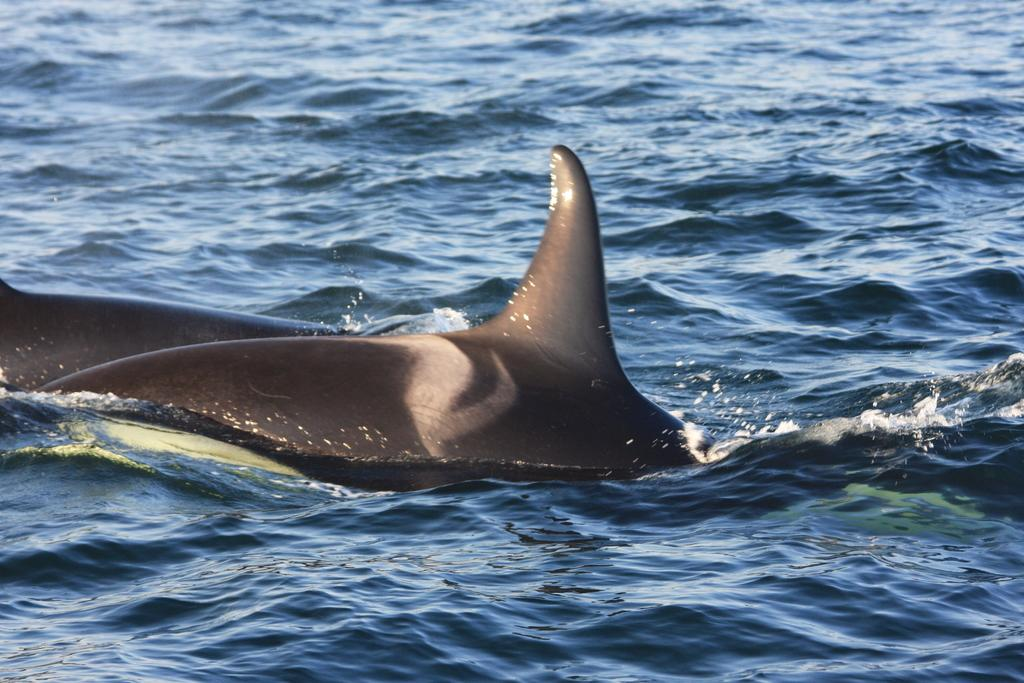What type of animals can be seen in the image? There are fish in the water. Can you describe the color of the fish? The fish is gray in color. What is the color of the water in the image? The water is blue in color. What type of bushes can be seen growing near the fish in the image? There are no bushes present in the image; it features fish in water. 